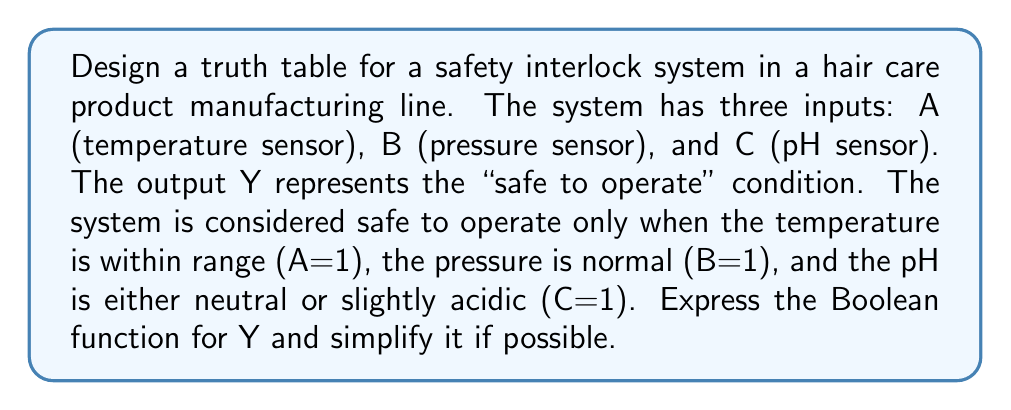Can you solve this math problem? Let's approach this step-by-step:

1) First, we need to create a truth table with all possible combinations of inputs A, B, and C:

   | A | B | C | Y |
   |---|---|---|---|
   | 0 | 0 | 0 | 0 |
   | 0 | 0 | 1 | 0 |
   | 0 | 1 | 0 | 0 |
   | 0 | 1 | 1 | 0 |
   | 1 | 0 | 0 | 0 |
   | 1 | 0 | 1 | 0 |
   | 1 | 1 | 0 | 0 |
   | 1 | 1 | 1 | 1 |

2) From the truth table, we can see that Y is only 1 when A, B, and C are all 1.

3) The Boolean function for Y can be expressed as:

   $$Y = A \cdot B \cdot C$$

4) This function is already in its simplest form, as it requires all inputs to be 1 for the output to be 1.

5) In Boolean algebra, this is known as an AND operation, which can also be written as:

   $$Y = A \land B \land C$$

6) This function ensures that the system is only considered safe to operate when all three conditions (temperature, pressure, and pH) are within their specified ranges.
Answer: $$Y = A \cdot B \cdot C$$ 